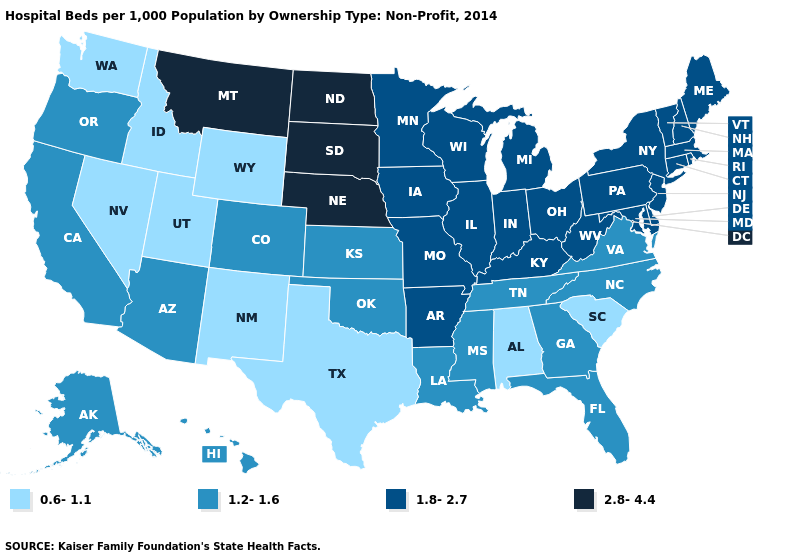What is the highest value in states that border Louisiana?
Give a very brief answer. 1.8-2.7. Name the states that have a value in the range 1.2-1.6?
Give a very brief answer. Alaska, Arizona, California, Colorado, Florida, Georgia, Hawaii, Kansas, Louisiana, Mississippi, North Carolina, Oklahoma, Oregon, Tennessee, Virginia. Which states have the highest value in the USA?
Give a very brief answer. Montana, Nebraska, North Dakota, South Dakota. What is the value of Alaska?
Give a very brief answer. 1.2-1.6. What is the value of Idaho?
Answer briefly. 0.6-1.1. Name the states that have a value in the range 0.6-1.1?
Short answer required. Alabama, Idaho, Nevada, New Mexico, South Carolina, Texas, Utah, Washington, Wyoming. What is the value of Alaska?
Concise answer only. 1.2-1.6. Name the states that have a value in the range 1.8-2.7?
Concise answer only. Arkansas, Connecticut, Delaware, Illinois, Indiana, Iowa, Kentucky, Maine, Maryland, Massachusetts, Michigan, Minnesota, Missouri, New Hampshire, New Jersey, New York, Ohio, Pennsylvania, Rhode Island, Vermont, West Virginia, Wisconsin. What is the value of Missouri?
Give a very brief answer. 1.8-2.7. Does Washington have the lowest value in the West?
Write a very short answer. Yes. Name the states that have a value in the range 2.8-4.4?
Answer briefly. Montana, Nebraska, North Dakota, South Dakota. Is the legend a continuous bar?
Answer briefly. No. Name the states that have a value in the range 1.8-2.7?
Quick response, please. Arkansas, Connecticut, Delaware, Illinois, Indiana, Iowa, Kentucky, Maine, Maryland, Massachusetts, Michigan, Minnesota, Missouri, New Hampshire, New Jersey, New York, Ohio, Pennsylvania, Rhode Island, Vermont, West Virginia, Wisconsin. Name the states that have a value in the range 0.6-1.1?
Write a very short answer. Alabama, Idaho, Nevada, New Mexico, South Carolina, Texas, Utah, Washington, Wyoming. Name the states that have a value in the range 2.8-4.4?
Give a very brief answer. Montana, Nebraska, North Dakota, South Dakota. 